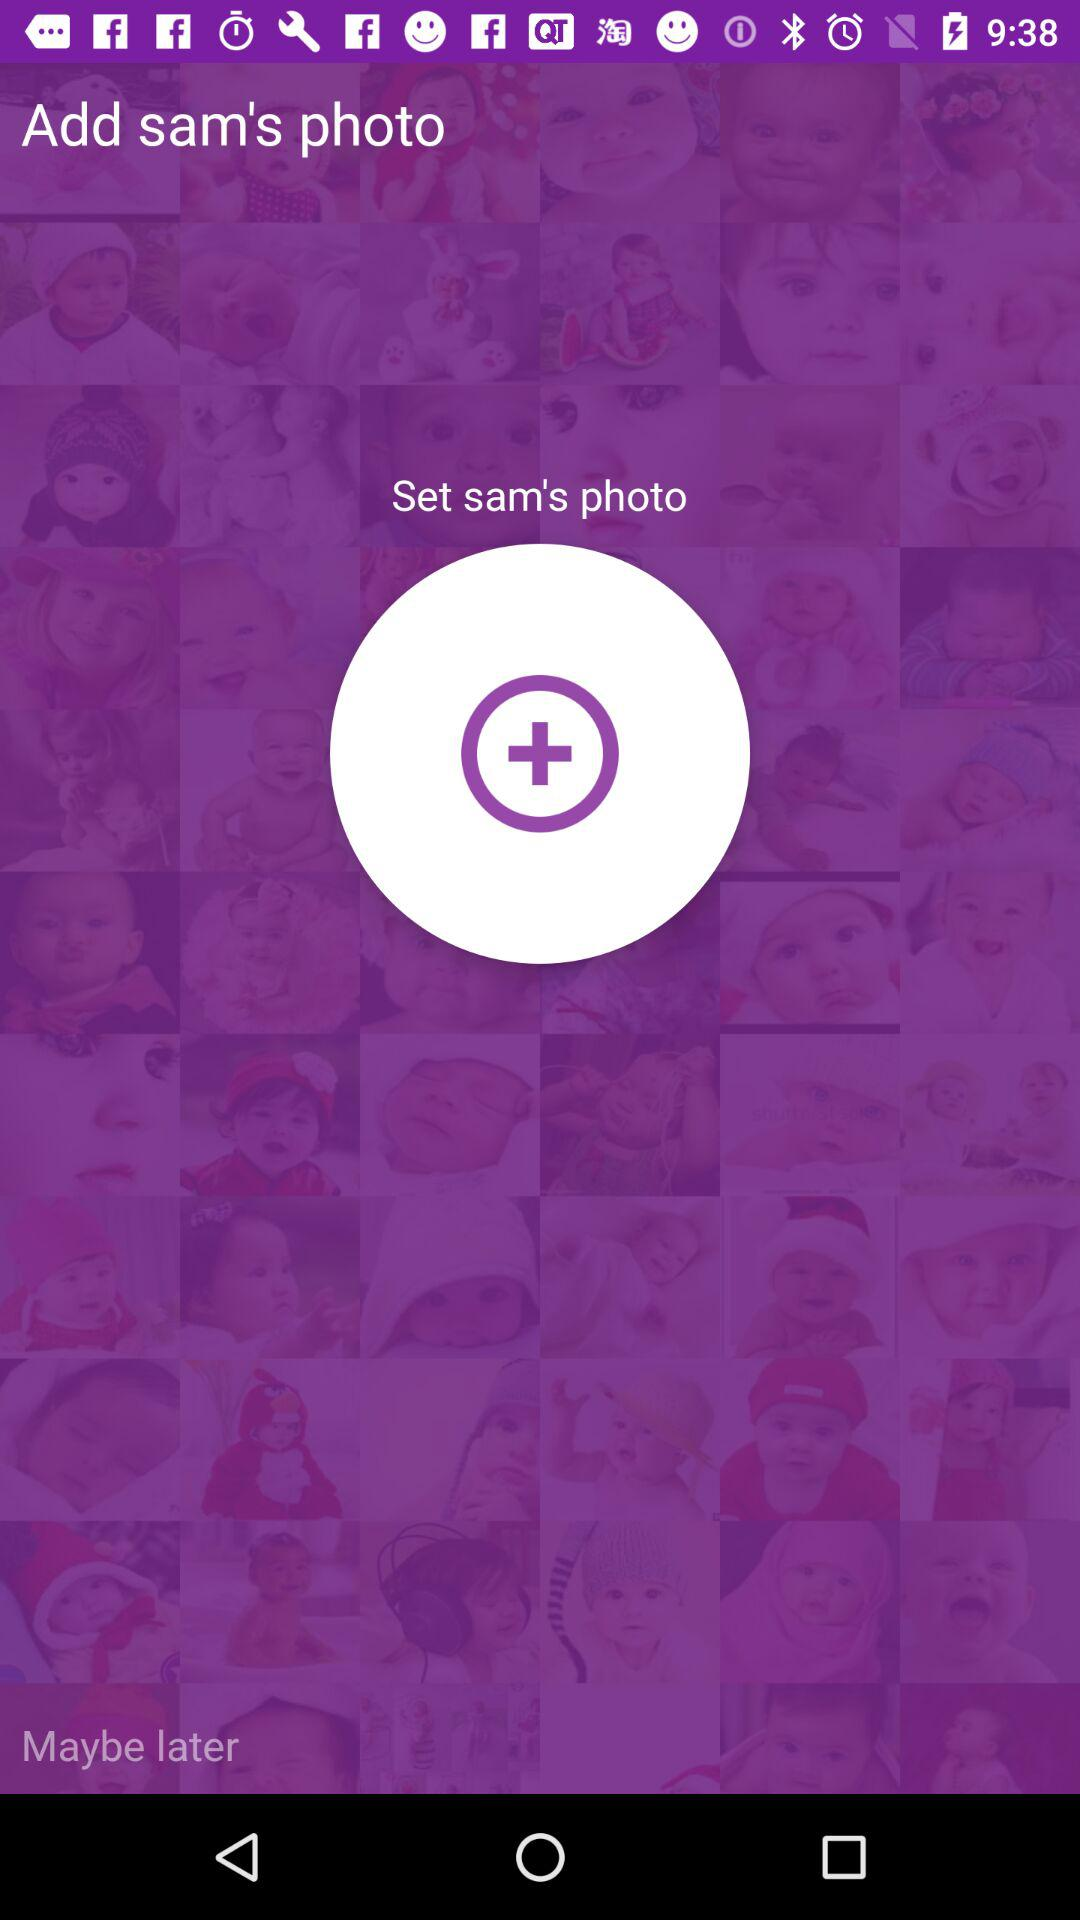What is the user name? The user name is Sam. 